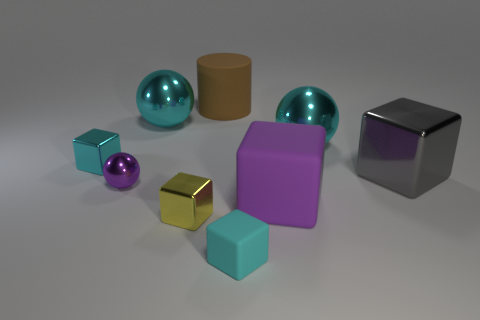Subtract 1 cubes. How many cubes are left? 4 Subtract all yellow cubes. How many cubes are left? 4 Subtract all purple cubes. How many cubes are left? 4 Subtract all brown blocks. Subtract all red cylinders. How many blocks are left? 5 Add 1 large shiny cylinders. How many objects exist? 10 Subtract all cylinders. How many objects are left? 8 Subtract 0 red cylinders. How many objects are left? 9 Subtract all cyan objects. Subtract all cyan matte blocks. How many objects are left? 4 Add 6 big gray blocks. How many big gray blocks are left? 7 Add 3 large cyan objects. How many large cyan objects exist? 5 